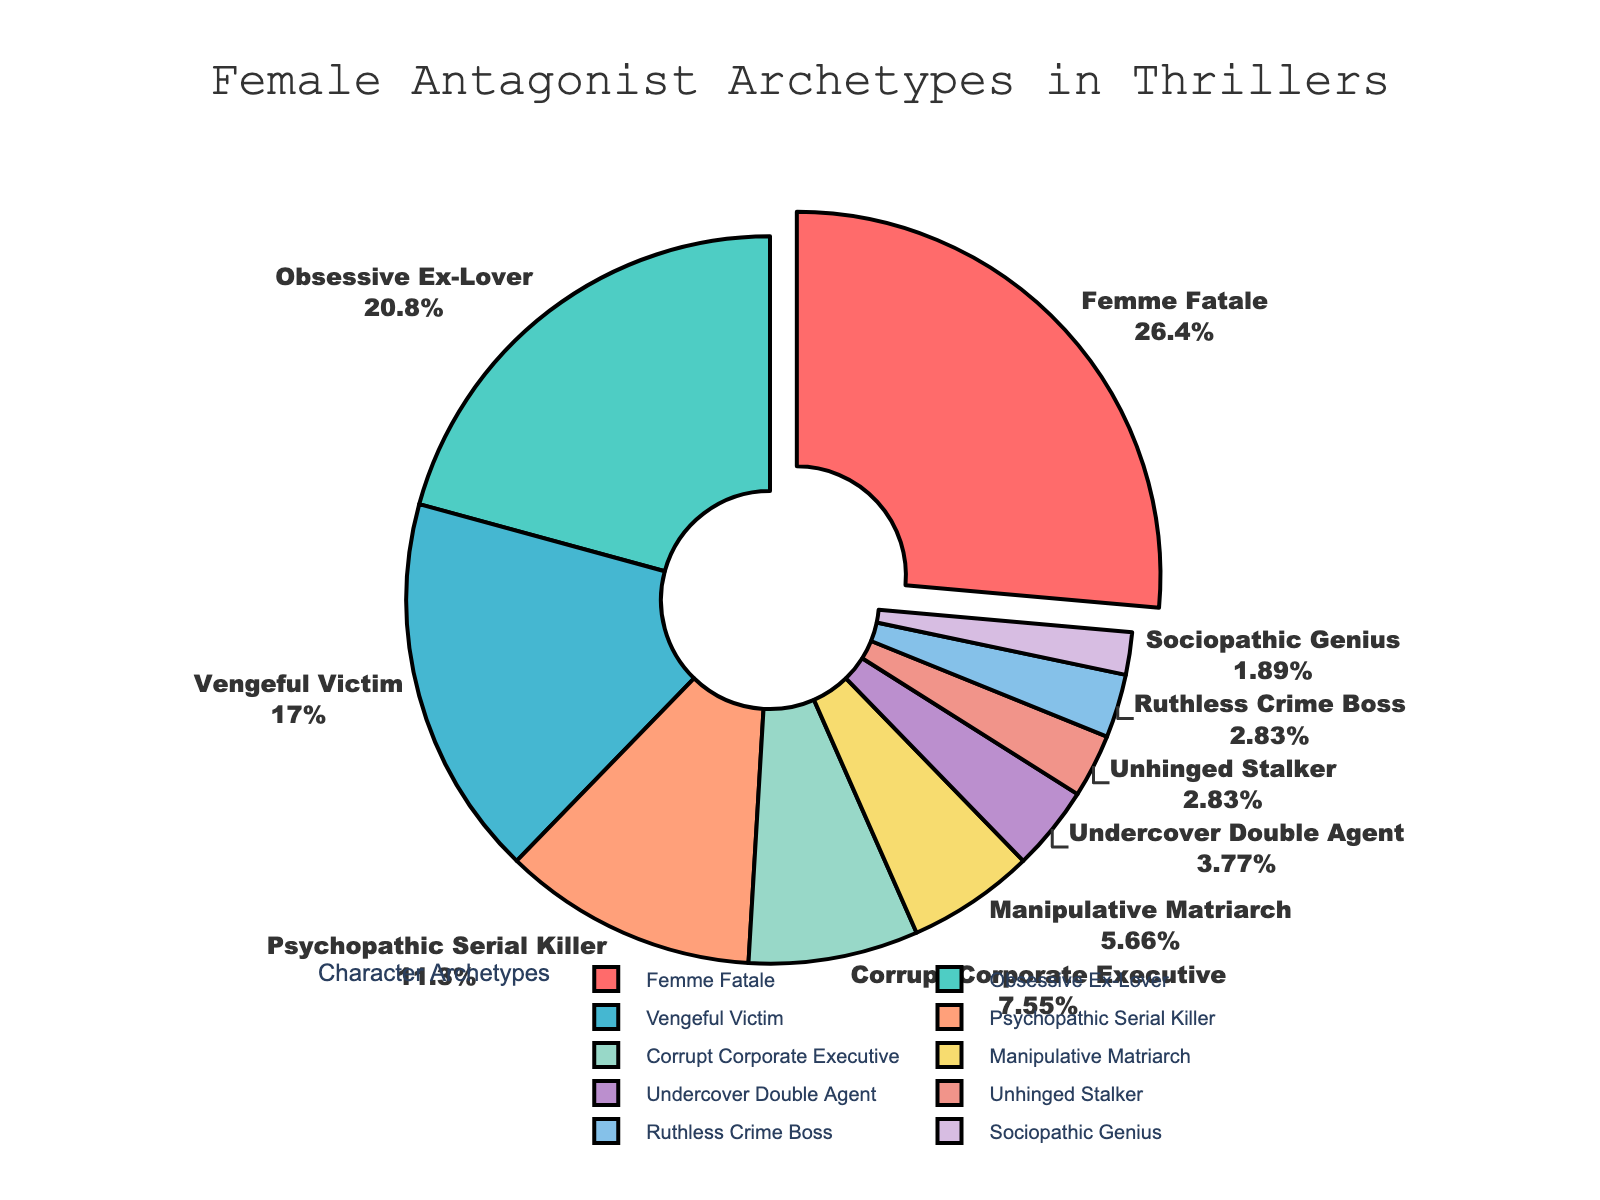Which character archetype represents the highest percentage of female antagonists in thriller movies? The pie chart indicates that the "Femme Fatale" is the archetype that covers the largest segment.
Answer: Femme Fatale Which character archetype has the second highest percentage? By looking at the pie chart, the second largest segment is for the "Obsessive Ex-Lover" archetype.
Answer: Obsessive Ex-Lover What is the combined percentage of "Sociopathic Genius" and "Undercover Double Agent"? The "Sociopathic Genius" has 2% and the "Undercover Double Agent" has 4%, so combined they make 2% + 4% = 6%.
Answer: 6% Which archetype has a larger percentage: "Psychopathic Serial Killer" or "Vengeful Victim"? The pie chart shows that the "Vengeful Victim" has 18% while the "Psychopathic Serial Killer" has 12%, so "Vengeful Victim" has a larger percentage.
Answer: Vengeful Victim How does the percentage of "Ruthless Crime Boss" compare to "Unhinged Stalker"? Both "Ruthless Crime Boss" and "Unhinged Stalker" have the same percentage, which is 3%.
Answer: Equal What is the total percentage represented by the three least common archetypes? The least common archetypes are "Undercover Double Agent" (4%), "Unhinged Stalker" (3%), and "Ruthless Crime Boss" (3%). The total is 4% + 3% + 3% = 10%.
Answer: 10% If you combine "Corrupt Corporate Executive" and "Manipulative Matriarch," what percentage do you get? "Corrupt Corporate Executive" has 8% and "Manipulative Matriarch" has 6%. Combined, they represent 8% + 6% = 14%.
Answer: 14% What is the difference in percentage between "Obsessive Ex-Lover" and "Psychopathic Serial Killer"? "Obsessive Ex-Lover" is 22% and "Psychopathic Serial Killer" is 12%. The difference is 22% - 12% = 10%.
Answer: 10% Are there any archetypes with less than 5% representation? If so, which ones? Yes, "Undercover Double Agent" (4%), "Unhinged Stalker" (3%), "Ruthless Crime Boss" (3%), and "Sociopathic Genius" (2%) each have less than 5% representation.
Answer: Undercover Double Agent, Unhinged Stalker, Ruthless Crime Boss, Sociopathic Genius Which colored segment represents the "Femme Fatale" archetype? The "Femme Fatale" archetype is highlighted by being pulled out slightly from the pie chart and is also represented by the color red.
Answer: Red 